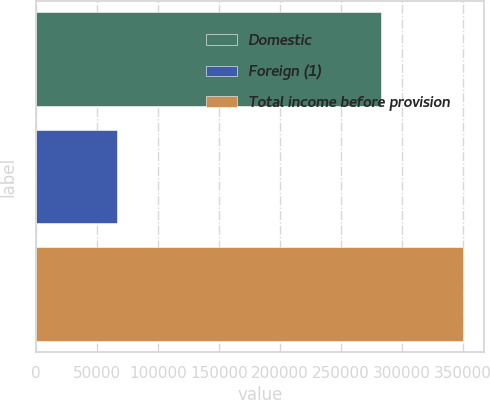<chart> <loc_0><loc_0><loc_500><loc_500><bar_chart><fcel>Domestic<fcel>Foreign (1)<fcel>Total income before provision<nl><fcel>282764<fcel>66790<fcel>349554<nl></chart> 